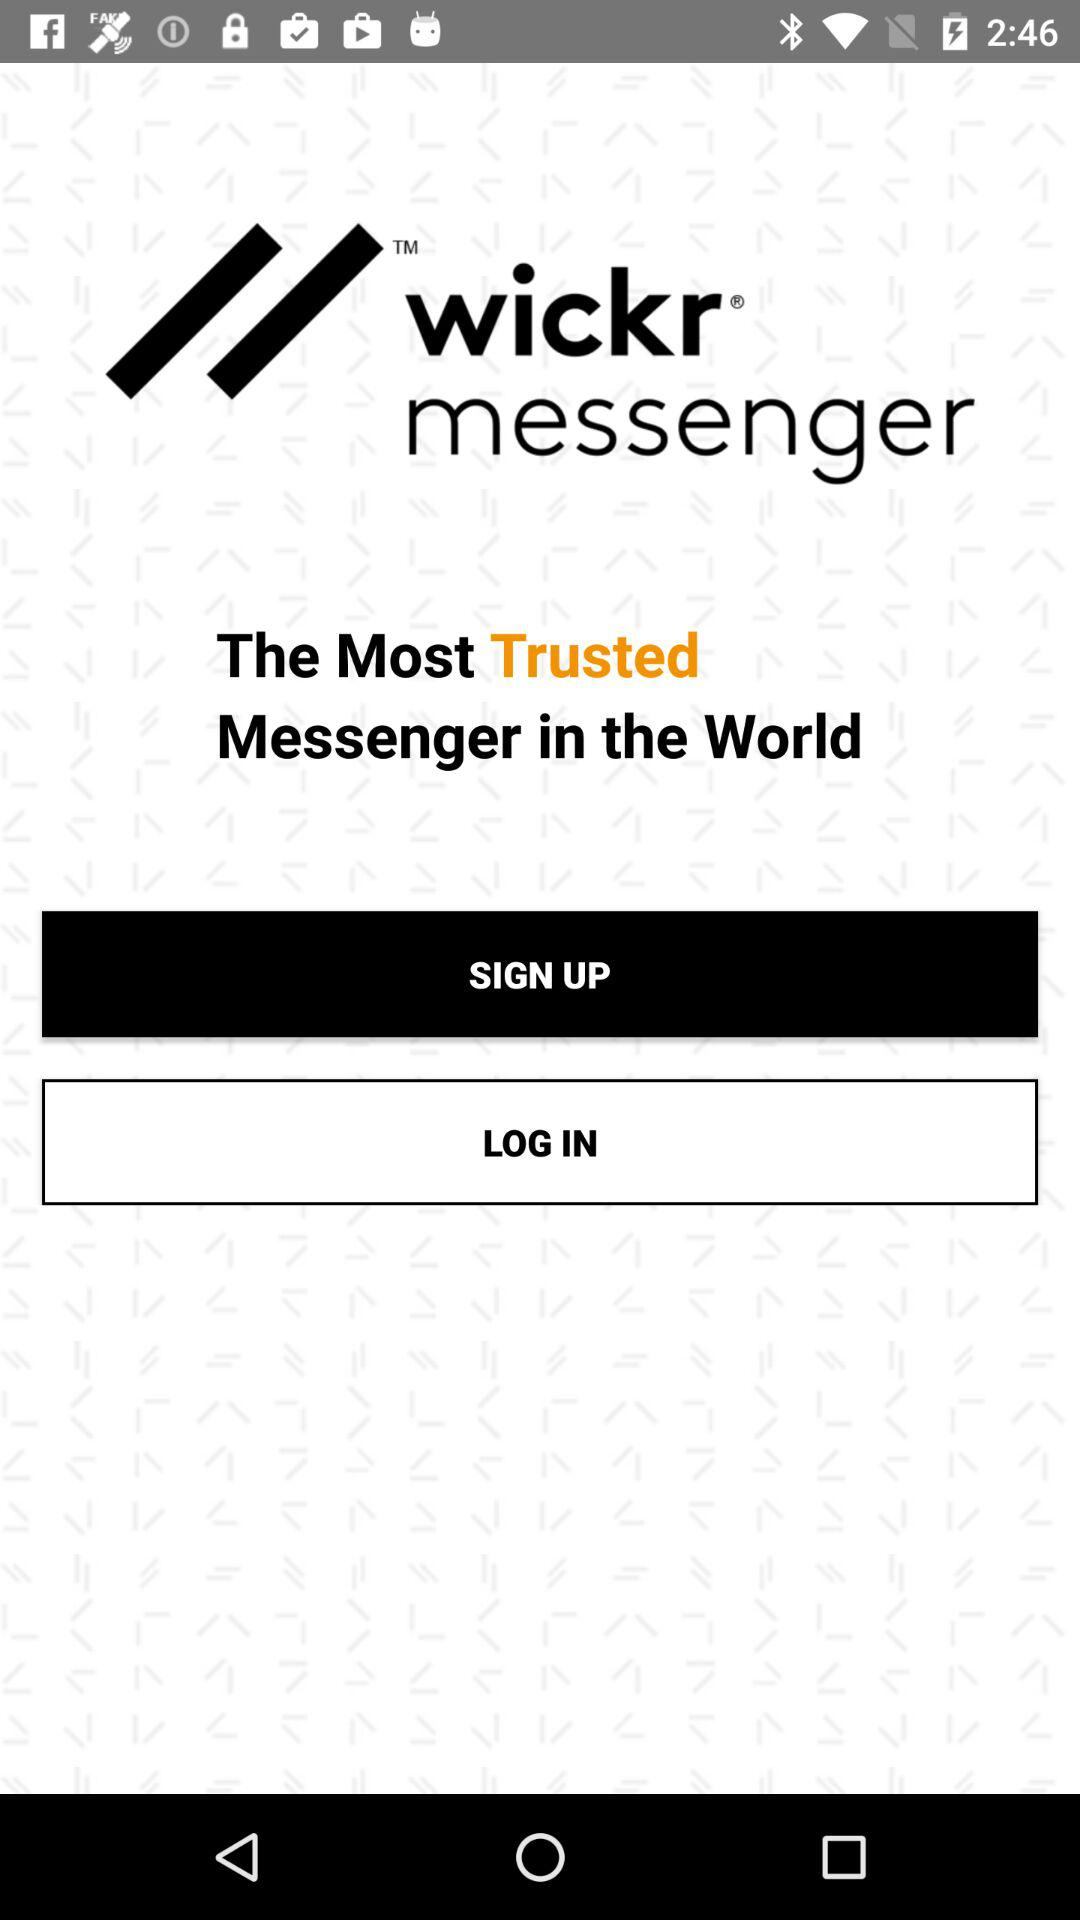What is the name of the most trusted messenger in the world? The name of the most trusted messenger in the world is Wickr Messenger. 